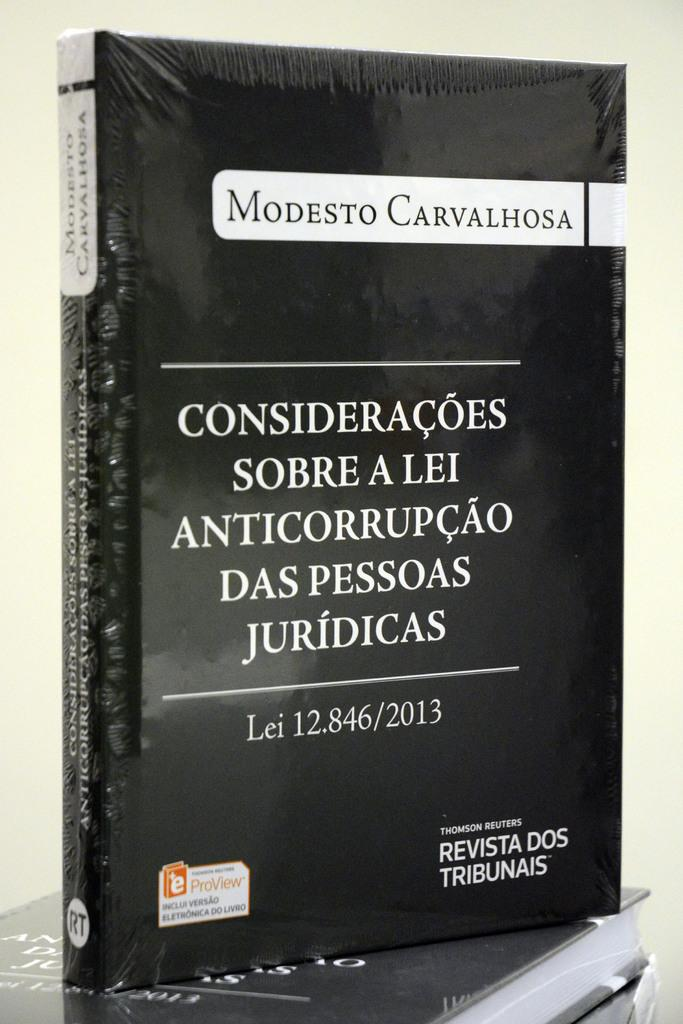Provide a one-sentence caption for the provided image. A book, wrapped in plastic, is titled Modesto Carvalhosa. 